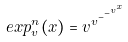<formula> <loc_0><loc_0><loc_500><loc_500>e x p _ { v } ^ { n } ( x ) = v ^ { v ^ { - ^ { - ^ { v ^ { x } } } } }</formula> 